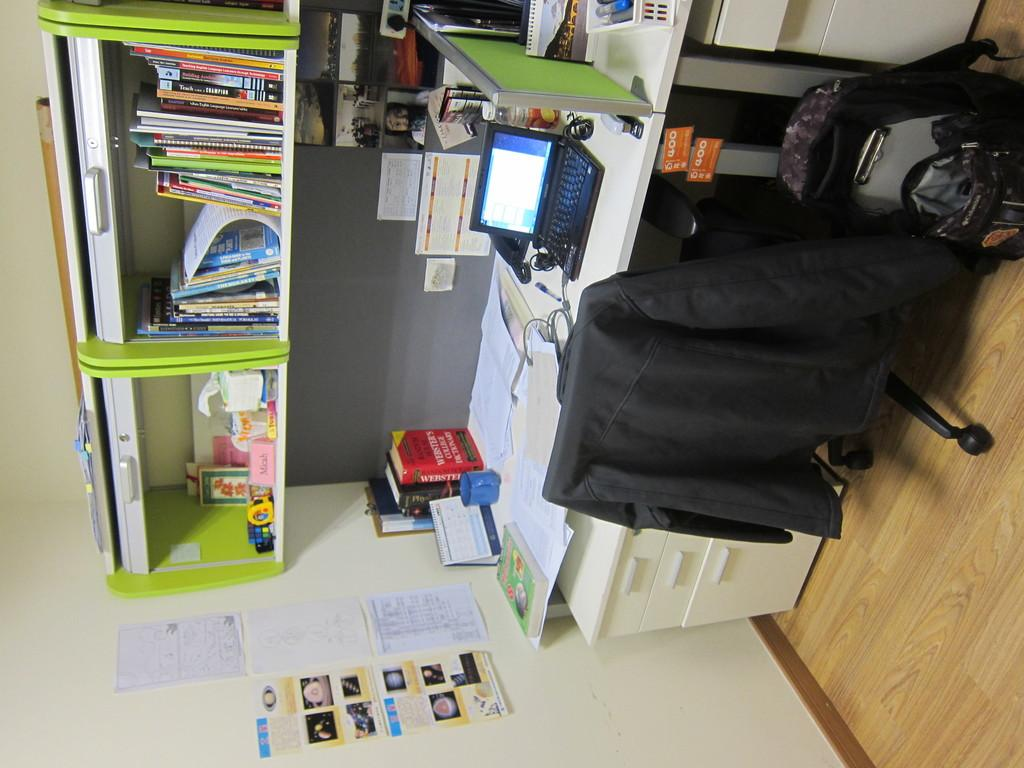<image>
Write a terse but informative summary of the picture. A sideways image of a person's desk shows a laptop and a Websters College Dictionary among many other items. 